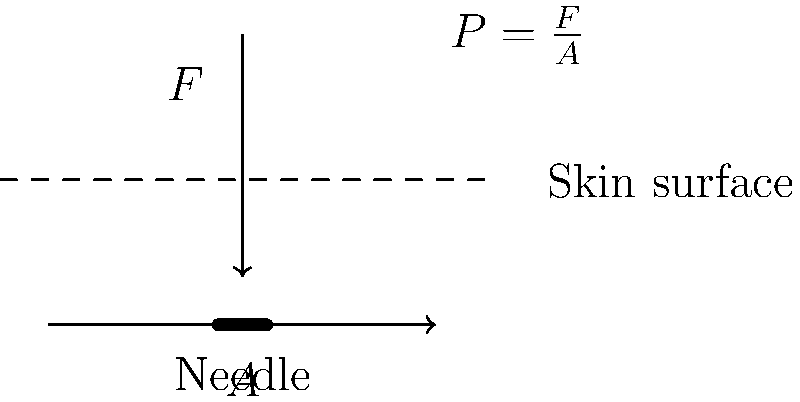During a tattoo session, a tattoo artist applies a force $F$ of 0.5 N to a needle with a tip area $A$ of 0.1 mm². What is the pressure $P$ exerted on the skin during the tattoo application? Express your answer in megapascals (MPa). To solve this problem, we'll use the formula for pressure:

$P = \frac{F}{A}$

Where:
$P$ is pressure (in Pa)
$F$ is force (in N)
$A$ is area (in m²)

Step 1: Convert the area from mm² to m²
$A = 0.1$ mm² = $0.1 \times 10^{-6}$ m²

Step 2: Apply the pressure formula
$P = \frac{F}{A} = \frac{0.5 \text{ N}}{0.1 \times 10^{-6} \text{ m}²}$

Step 3: Calculate the result
$P = 5 \times 10^6$ Pa

Step 4: Convert Pa to MPa
$5 \times 10^6$ Pa = 5 MPa

Therefore, the pressure exerted on the skin during the tattoo application is 5 MPa.
Answer: 5 MPa 